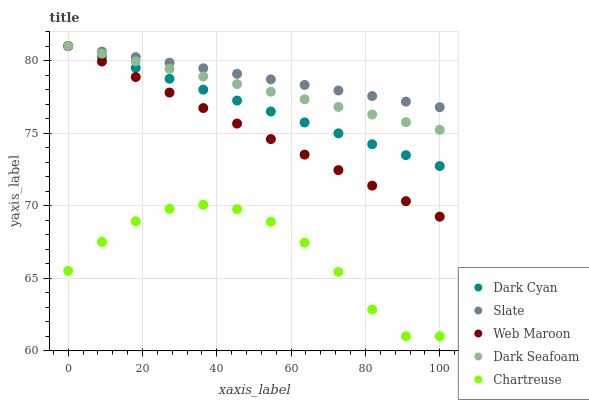Does Chartreuse have the minimum area under the curve?
Answer yes or no. Yes. Does Slate have the maximum area under the curve?
Answer yes or no. Yes. Does Web Maroon have the minimum area under the curve?
Answer yes or no. No. Does Web Maroon have the maximum area under the curve?
Answer yes or no. No. Is Web Maroon the smoothest?
Answer yes or no. Yes. Is Chartreuse the roughest?
Answer yes or no. Yes. Is Slate the smoothest?
Answer yes or no. No. Is Slate the roughest?
Answer yes or no. No. Does Chartreuse have the lowest value?
Answer yes or no. Yes. Does Web Maroon have the lowest value?
Answer yes or no. No. Does Dark Seafoam have the highest value?
Answer yes or no. Yes. Does Chartreuse have the highest value?
Answer yes or no. No. Is Chartreuse less than Dark Cyan?
Answer yes or no. Yes. Is Dark Cyan greater than Chartreuse?
Answer yes or no. Yes. Does Dark Cyan intersect Dark Seafoam?
Answer yes or no. Yes. Is Dark Cyan less than Dark Seafoam?
Answer yes or no. No. Is Dark Cyan greater than Dark Seafoam?
Answer yes or no. No. Does Chartreuse intersect Dark Cyan?
Answer yes or no. No. 